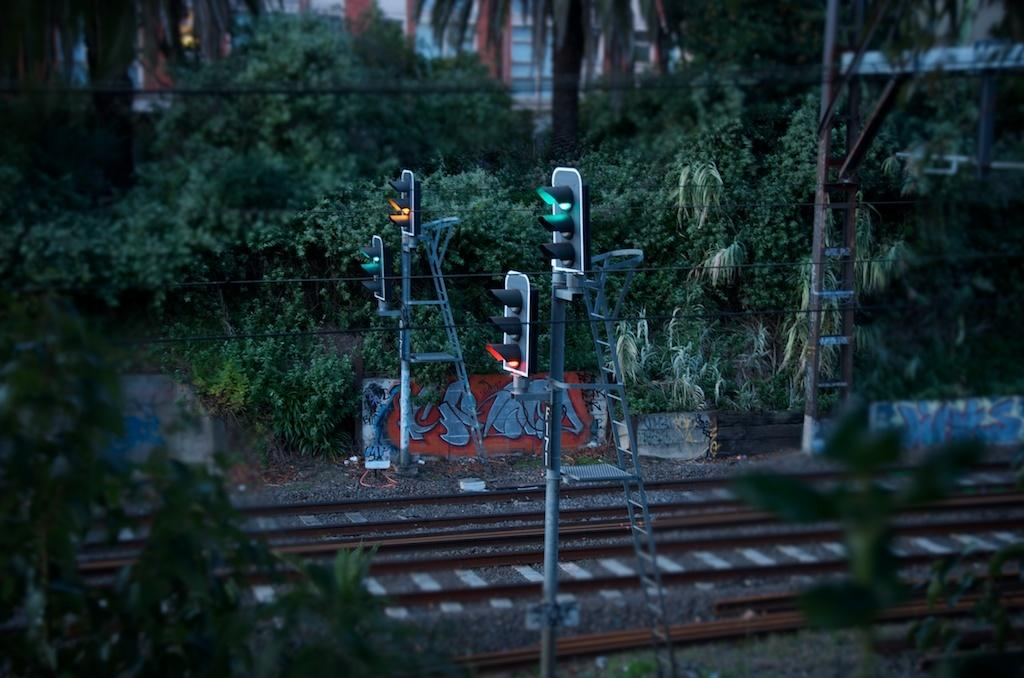What type of signaling device is present in the image? There are traffic lights in the image. What structures support the traffic lights and other objects in the image? There are poles in the image. What tools are visible in the image for reaching higher places? There are ladders in the image. What type of artwork can be seen on the wall in the image? There are paintings on the wall in the image. What type of natural vegetation is present in the image? There are trees in the image. What type of transportation infrastructure is present in the image? There are train tracks in the image. What type of electrical infrastructure is present in the image? There are wires in the image. What type of residential structures are present in the image? There are houses in the image. What type of brick is used to construct the train tracks in the image? There is no mention of brick in the image, and train tracks are typically made of steel or concrete, not brick. What is the condition of the industry depicted in the image? There is no industry depicted in the image, so it is not possible to determine its condition. 